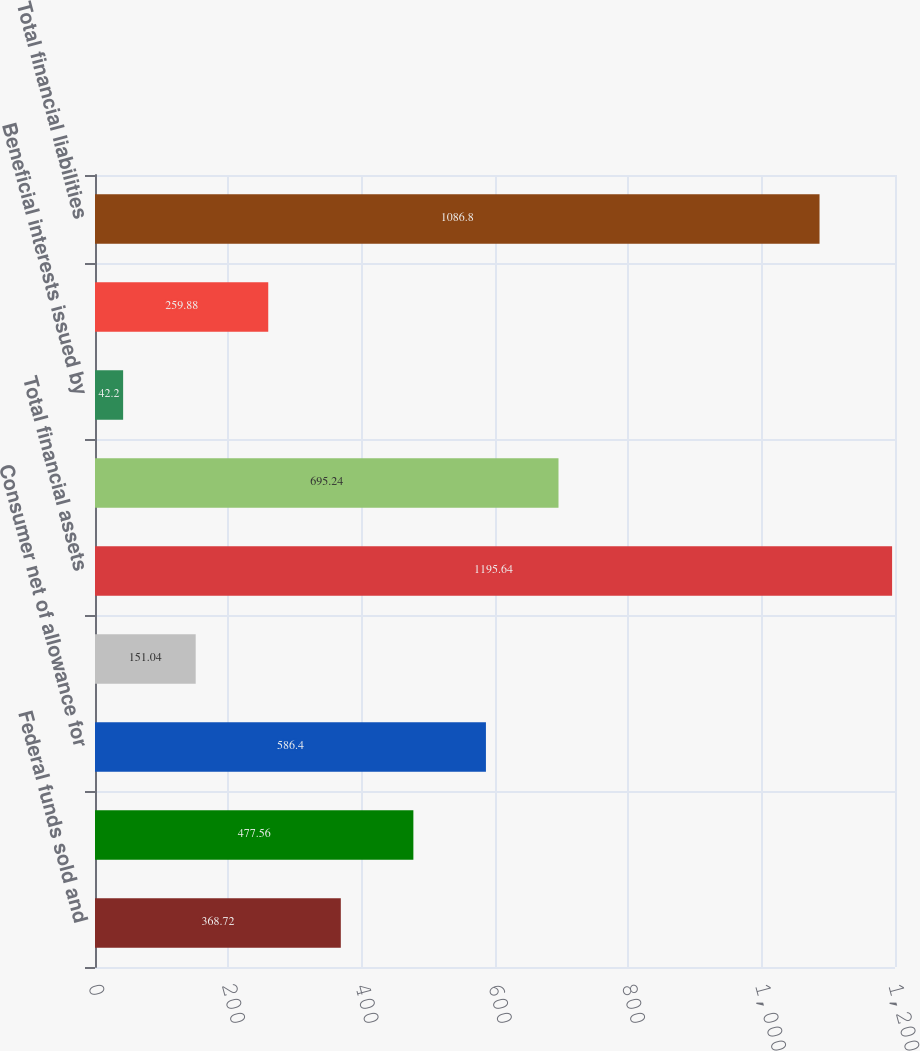Convert chart. <chart><loc_0><loc_0><loc_500><loc_500><bar_chart><fcel>Federal funds sold and<fcel>Loans Wholesale net of<fcel>Consumer net of allowance for<fcel>Other assets<fcel>Total financial assets<fcel>Interest-bearing deposits<fcel>Beneficial interests issued by<fcel>Long-term debt-related<fcel>Total financial liabilities<nl><fcel>368.72<fcel>477.56<fcel>586.4<fcel>151.04<fcel>1195.64<fcel>695.24<fcel>42.2<fcel>259.88<fcel>1086.8<nl></chart> 